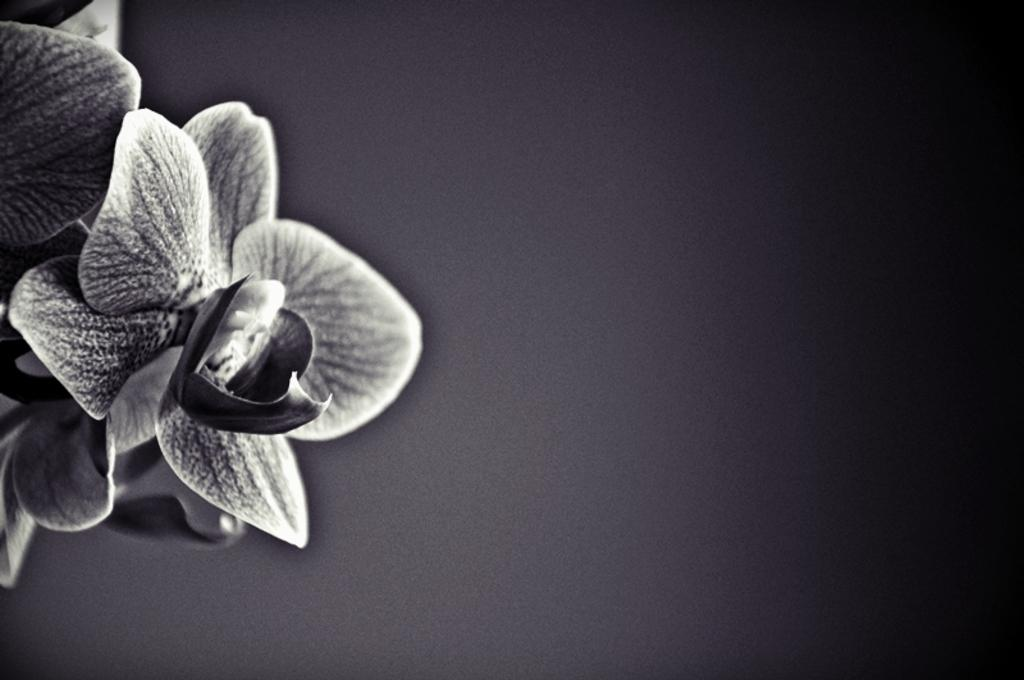What type of vegetation can be seen on the left side of the image? There are flowers on the left side of the image. How would you describe the overall lighting in the image? The background of the image is dark. Where is the plant located in the image? There is no plant mentioned in the facts provided; only flowers are mentioned. Can you tell me how many servants are visible in the image? There is no mention of servants in the image, so it cannot be determined from the facts provided. 